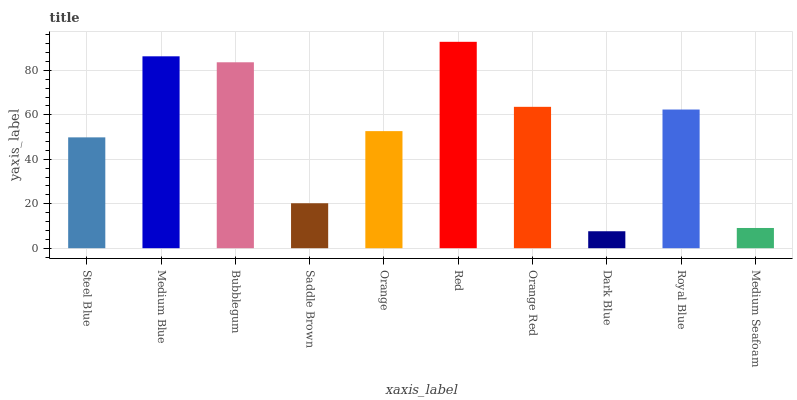Is Dark Blue the minimum?
Answer yes or no. Yes. Is Red the maximum?
Answer yes or no. Yes. Is Medium Blue the minimum?
Answer yes or no. No. Is Medium Blue the maximum?
Answer yes or no. No. Is Medium Blue greater than Steel Blue?
Answer yes or no. Yes. Is Steel Blue less than Medium Blue?
Answer yes or no. Yes. Is Steel Blue greater than Medium Blue?
Answer yes or no. No. Is Medium Blue less than Steel Blue?
Answer yes or no. No. Is Royal Blue the high median?
Answer yes or no. Yes. Is Orange the low median?
Answer yes or no. Yes. Is Medium Seafoam the high median?
Answer yes or no. No. Is Royal Blue the low median?
Answer yes or no. No. 